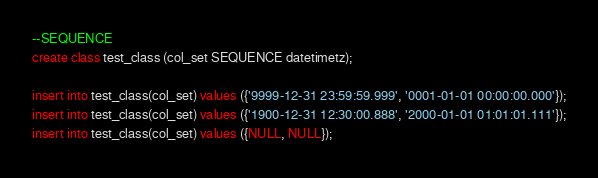Convert code to text. <code><loc_0><loc_0><loc_500><loc_500><_SQL_>--SEQUENCE
create class test_class (col_set SEQUENCE datetimetz);

insert into test_class(col_set) values ({'9999-12-31 23:59:59.999', '0001-01-01 00:00:00.000'});
insert into test_class(col_set) values ({'1900-12-31 12:30:00.888', '2000-01-01 01:01:01.111'});
insert into test_class(col_set) values ({NULL, NULL});</code> 